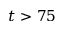Convert formula to latex. <formula><loc_0><loc_0><loc_500><loc_500>t > 7 5</formula> 